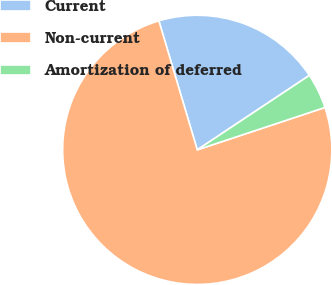<chart> <loc_0><loc_0><loc_500><loc_500><pie_chart><fcel>Current<fcel>Non-current<fcel>Amortization of deferred<nl><fcel>20.27%<fcel>75.5%<fcel>4.23%<nl></chart> 